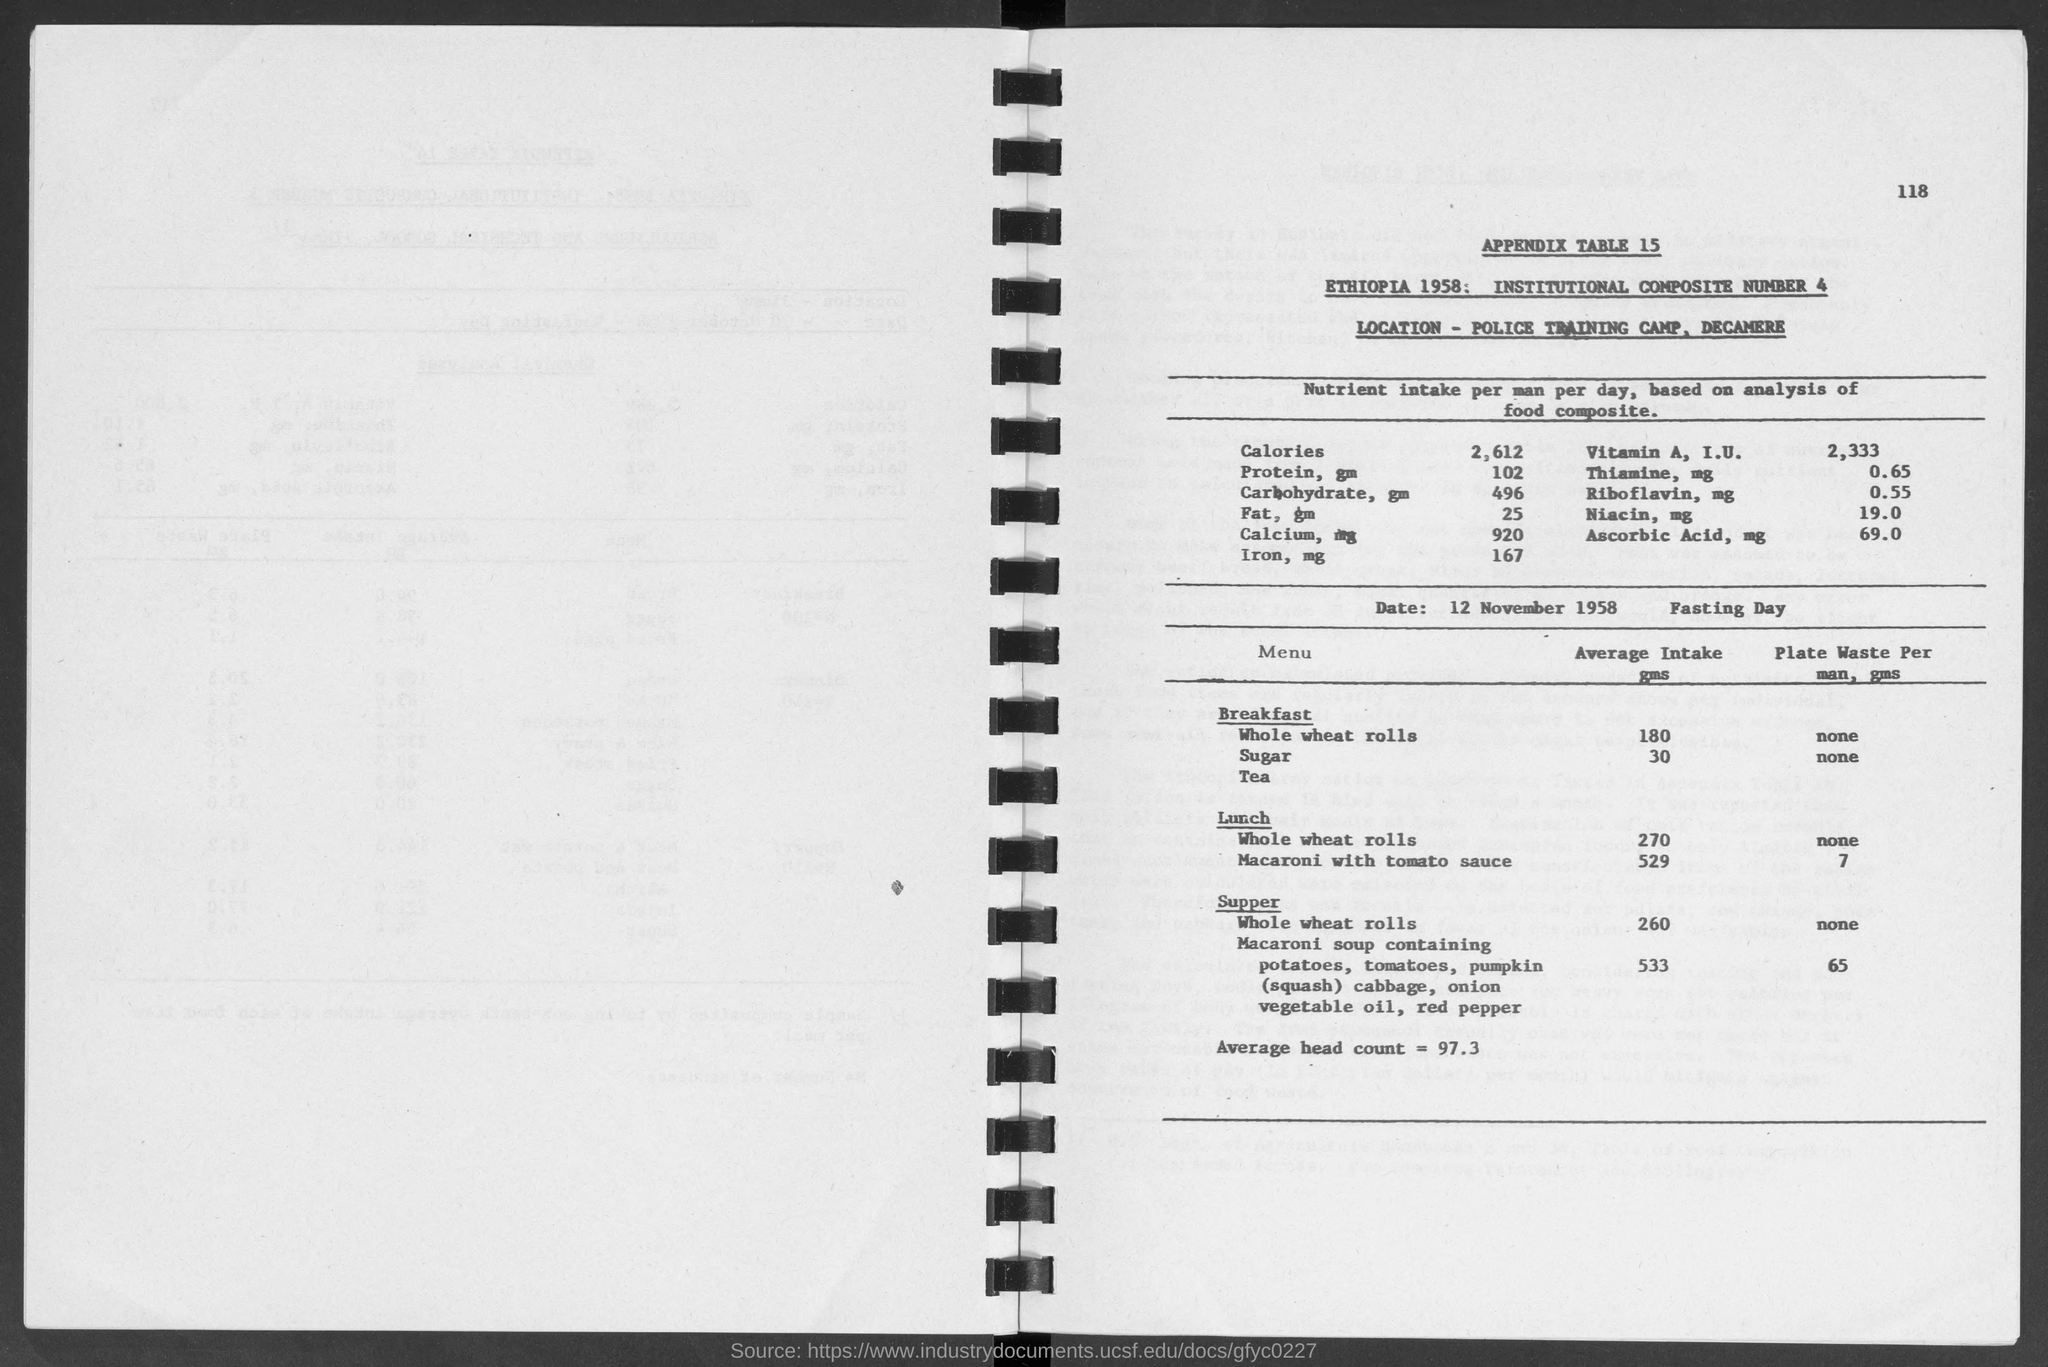List a handful of essential elements in this visual. According to the information provided, the average intake of whole wheat rolls in breakfast is approximately 180. The average head count is equal to 97.3. The average intake of whole wheat rolls in supper is approximately 260 grams. The date on the calendar beside the fasting day is 12 November 1958. On average, people consume approximately 30 grams of sugar in their breakfast each day. 